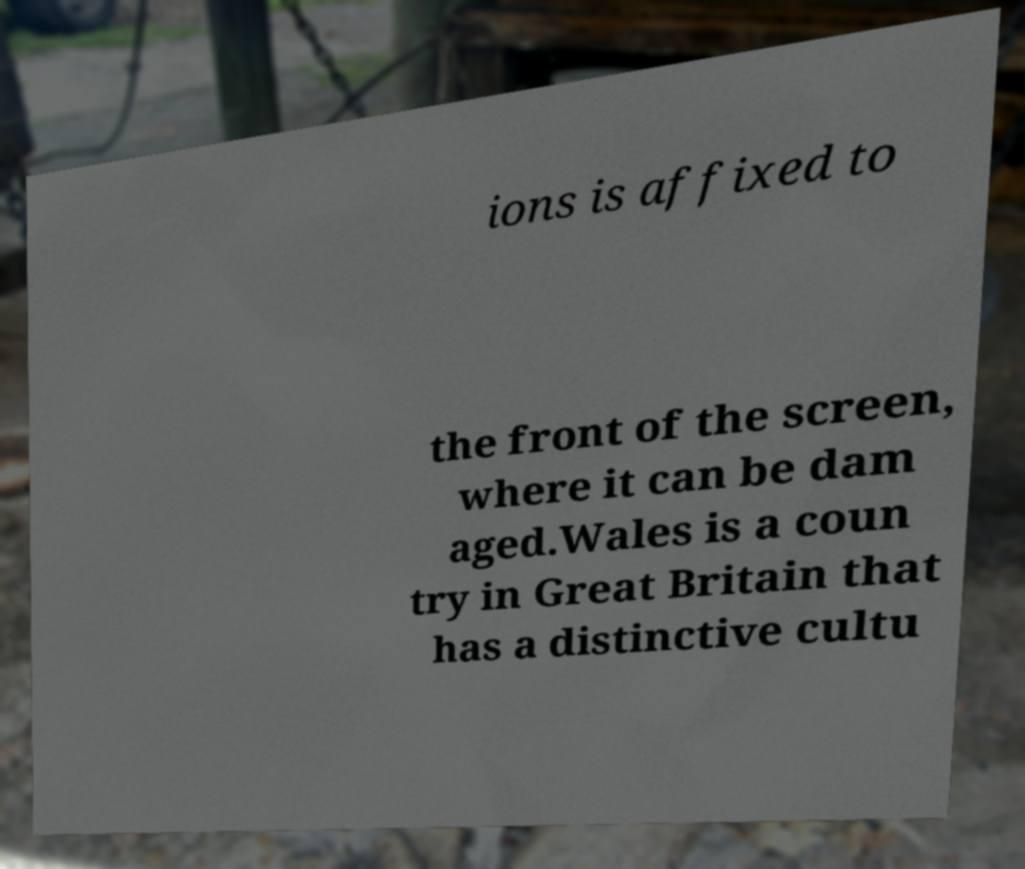Could you extract and type out the text from this image? ions is affixed to the front of the screen, where it can be dam aged.Wales is a coun try in Great Britain that has a distinctive cultu 